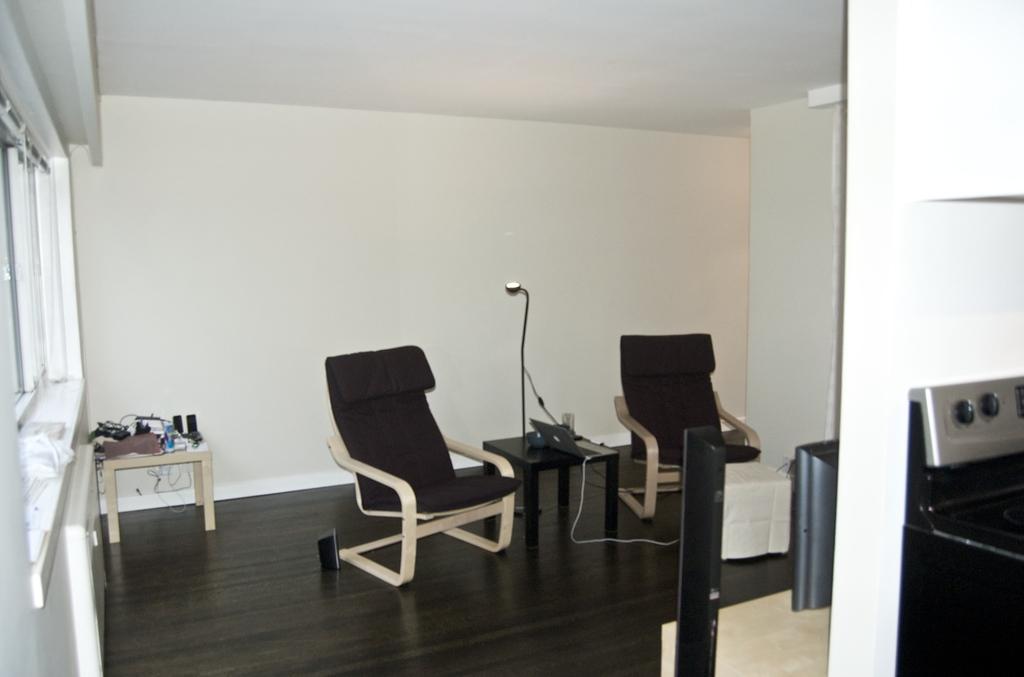In one or two sentences, can you explain what this image depicts? These are the chairs in the left side it looks like a window. 